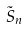<formula> <loc_0><loc_0><loc_500><loc_500>\tilde { S } _ { n }</formula> 